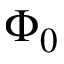Convert formula to latex. <formula><loc_0><loc_0><loc_500><loc_500>\Phi _ { 0 }</formula> 